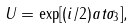<formula> <loc_0><loc_0><loc_500><loc_500>U = \exp [ ( i / 2 ) a t \sigma _ { 3 } ] ,</formula> 